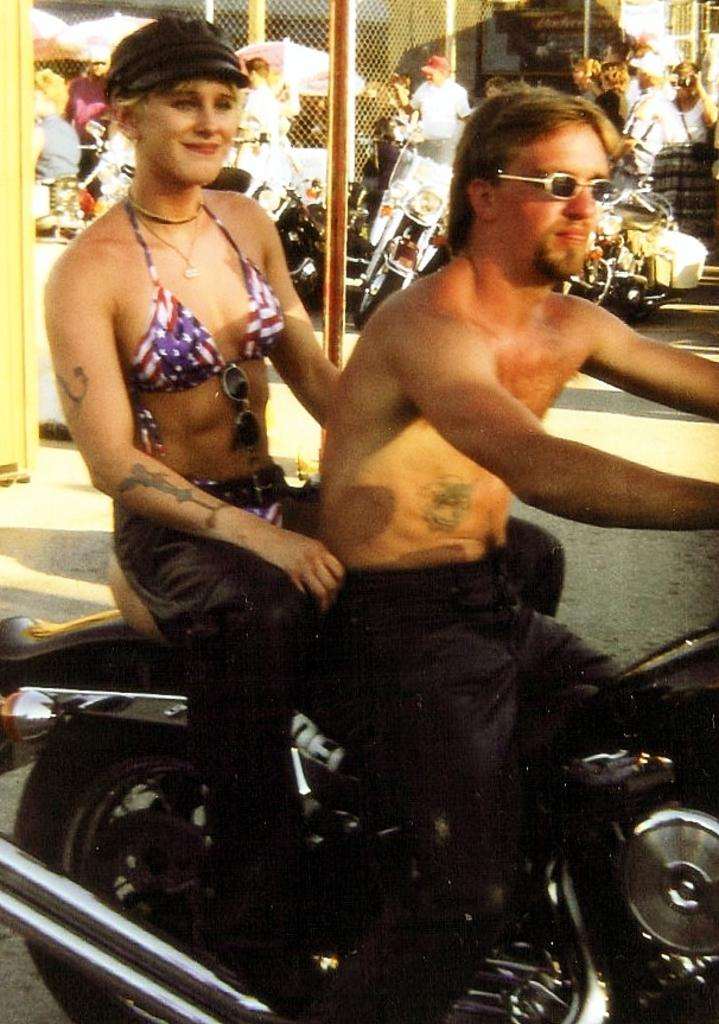Who are the people in the image? There is a woman and a man in the image. What are they doing in the image? The woman and the man are sitting on a bike. What accessories are they wearing? The man is wearing goggles, and the woman is wearing a hat. What can be seen in the background of the image? There are people and vehicles in the distance. What type of winter sport are they participating in the image? There is no indication of a winter sport in the image; the subjects are sitting on a bike, not engaging in any winter activities. 